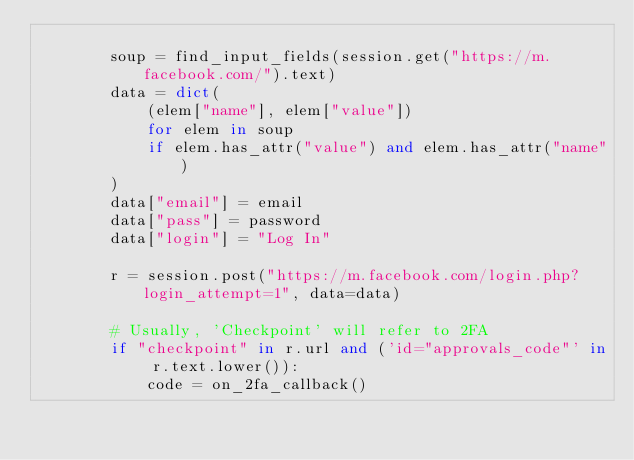Convert code to text. <code><loc_0><loc_0><loc_500><loc_500><_Python_>
        soup = find_input_fields(session.get("https://m.facebook.com/").text)
        data = dict(
            (elem["name"], elem["value"])
            for elem in soup
            if elem.has_attr("value") and elem.has_attr("name")
        )
        data["email"] = email
        data["pass"] = password
        data["login"] = "Log In"

        r = session.post("https://m.facebook.com/login.php?login_attempt=1", data=data)

        # Usually, 'Checkpoint' will refer to 2FA
        if "checkpoint" in r.url and ('id="approvals_code"' in r.text.lower()):
            code = on_2fa_callback()</code> 